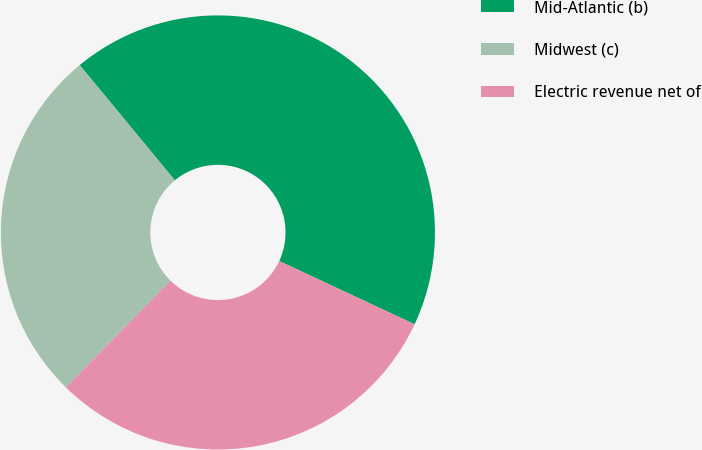Convert chart to OTSL. <chart><loc_0><loc_0><loc_500><loc_500><pie_chart><fcel>Mid-Atlantic (b)<fcel>Midwest (c)<fcel>Electric revenue net of<nl><fcel>42.94%<fcel>26.65%<fcel>30.41%<nl></chart> 